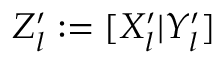<formula> <loc_0><loc_0><loc_500><loc_500>Z _ { l } ^ { \prime } \colon = [ X _ { l } ^ { \prime } | Y _ { l } ^ { \prime } ]</formula> 